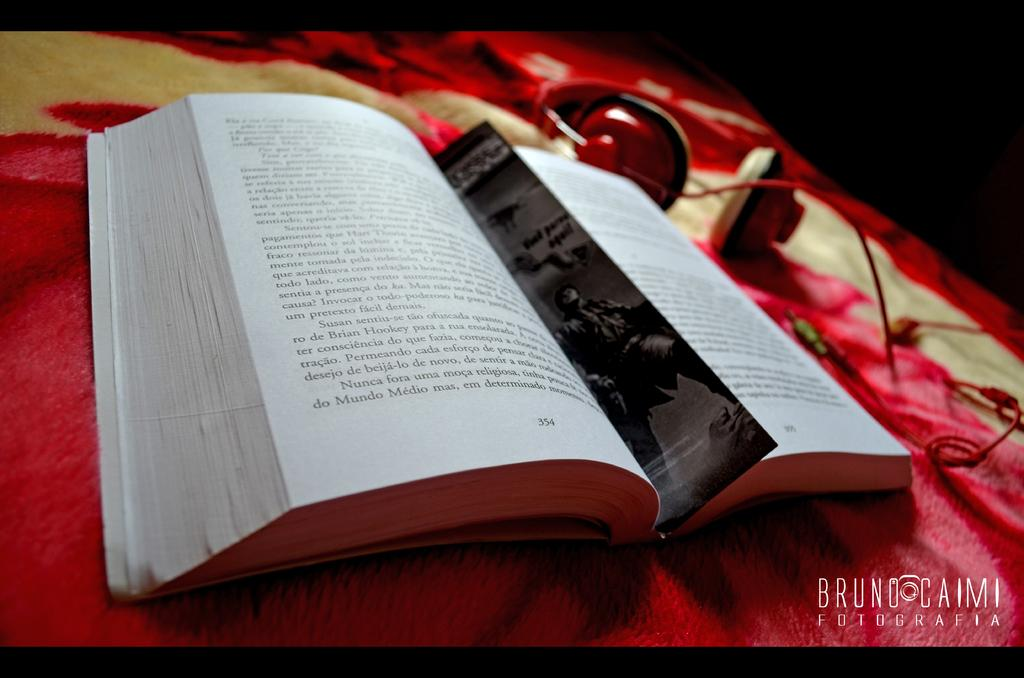<image>
Render a clear and concise summary of the photo. Book and headphones that contain the title Bruno Caimi: Fotografia. 